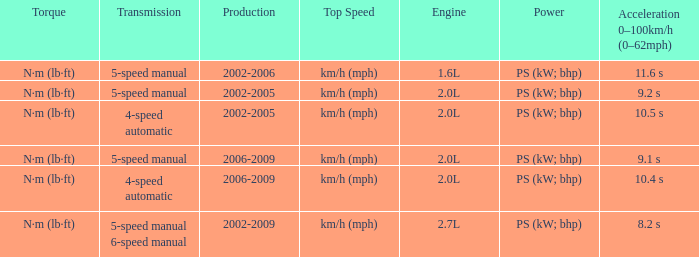What is the top speed of a 4-speed automatic with production in 2002-2005? Km/h (mph). Parse the full table. {'header': ['Torque', 'Transmission', 'Production', 'Top Speed', 'Engine', 'Power', 'Acceleration 0–100km/h (0–62mph)'], 'rows': [['N·m (lb·ft)', '5-speed manual', '2002-2006', 'km/h (mph)', '1.6L', 'PS (kW; bhp)', '11.6 s'], ['N·m (lb·ft)', '5-speed manual', '2002-2005', 'km/h (mph)', '2.0L', 'PS (kW; bhp)', '9.2 s'], ['N·m (lb·ft)', '4-speed automatic', '2002-2005', 'km/h (mph)', '2.0L', 'PS (kW; bhp)', '10.5 s'], ['N·m (lb·ft)', '5-speed manual', '2006-2009', 'km/h (mph)', '2.0L', 'PS (kW; bhp)', '9.1 s'], ['N·m (lb·ft)', '4-speed automatic', '2006-2009', 'km/h (mph)', '2.0L', 'PS (kW; bhp)', '10.4 s'], ['N·m (lb·ft)', '5-speed manual 6-speed manual', '2002-2009', 'km/h (mph)', '2.7L', 'PS (kW; bhp)', '8.2 s']]} 